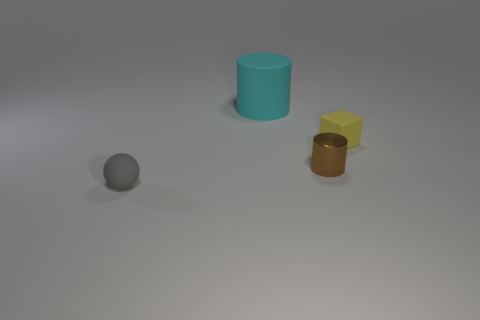Add 4 gray things. How many objects exist? 8 Subtract all cubes. How many objects are left? 3 Add 4 tiny gray things. How many tiny gray things are left? 5 Add 2 rubber balls. How many rubber balls exist? 3 Subtract 0 yellow spheres. How many objects are left? 4 Subtract all tiny brown objects. Subtract all small shiny cylinders. How many objects are left? 2 